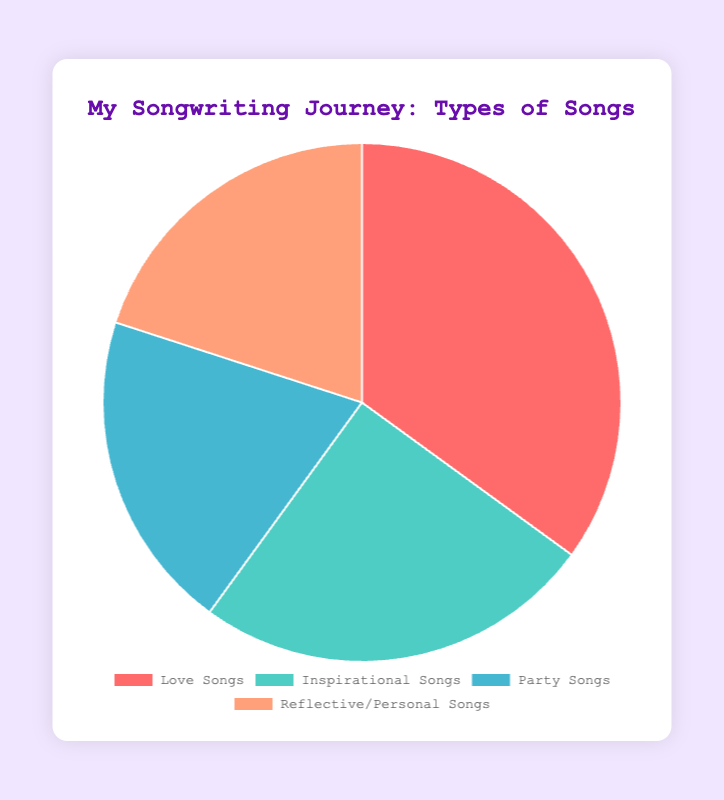Which type of song has the highest percentage? Love Songs has the highest percentage. By looking at the figure, Love Songs occupies the largest segment of the pie.
Answer: Love Songs Between Party Songs and Inspirational Songs, which has a lower percentage? Party Songs have a lower percentage compared to Inspirational Songs. By comparing the sizes of their segments, Party Songs are smaller.
Answer: Party Songs What is the combined percentage of Party Songs and Reflective/Personal Songs? The combined percentage is the sum of Party Songs and Reflective/Personal Songs. Party Songs are 20% and Reflective/Personal Songs are 20%: 20% + 20% = 40%.
Answer: 40% How much greater is the percentage of Love Songs compared to Party Songs? Subtract the percentage of Party Songs from Love Songs. Love Songs are 35%, while Party Songs are 20%. So, 35% - 20% = 15%.
Answer: 15% What is the average percentage of the four types of songs? The average percentage is calculated by summing the percentages and dividing by the number of types. (35% + 25% + 20% + 20%) / 4 = 25%.
Answer: 25% Which type of song has an equal percentage to Party Songs? Reflective/Personal Songs have the same percentage as Party Songs. Both are 20%.
Answer: Reflective/Personal Songs Which song types together make up more than 50% of all songs? Love Songs (35%) and Inspirational Songs (25%) together make up more than 50%: 35% + 25% = 60%.
Answer: Love Songs and Inspirational Songs If you were to combine Love Songs and Inspirational Songs into a new category, what percentage would that new category represent? The new category is the sum of Love Songs and Inspirational Songs. Love Songs are 35% and Inspirational Songs are 25%. So, 35% + 25% = 60%.
Answer: 60% Which color corresponds to Reflective/Personal Songs in the figure? Reflective/Personal Songs are represented by the light orange color in the pie chart. This can be identified by matching the segment color to the legend.
Answer: Light Orange Compare the percentage difference between Inspirational Songs and Reflective/Personal Songs. Subtract the percentage of Reflective/Personal Songs from Inspirational Songs. Inspirational Songs are 25%, while Reflective/Personal Songs are 20%. So, 25% - 20% = 5%.
Answer: 5% 